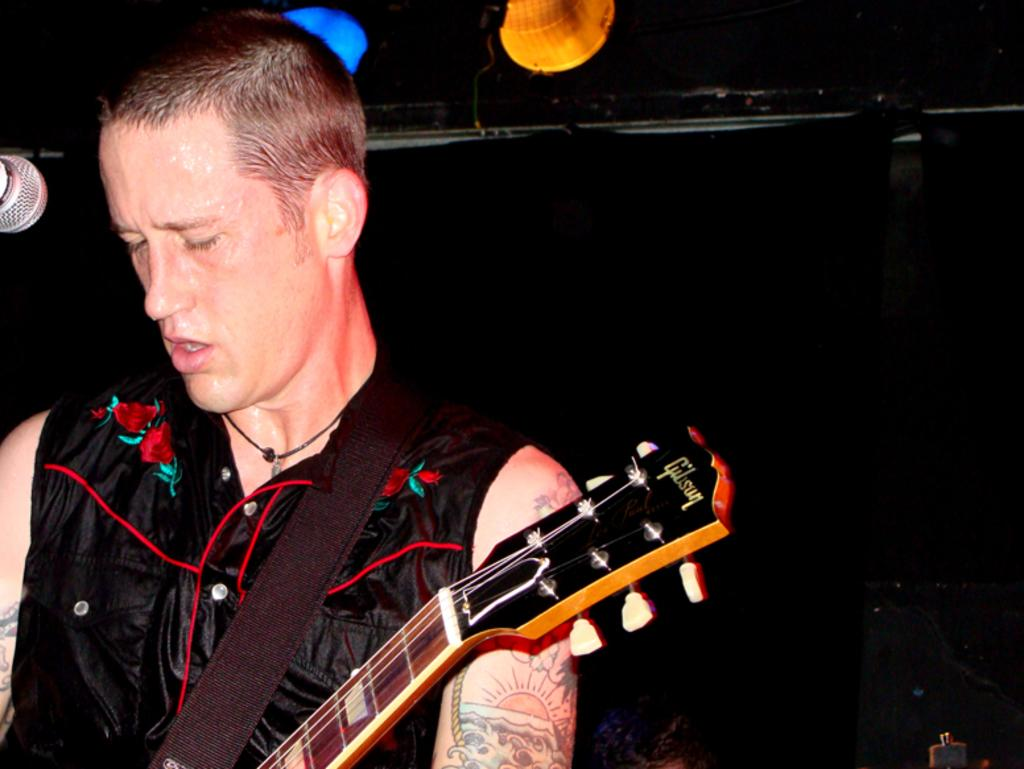What is the person in the image holding? The person is holding a musical instrument in the image. What device is present for amplifying sound? There is a microphone in the image. What can be seen in the image that provides illumination? There are lights in the image. How would you describe the overall lighting in the image? The background of the image is dark. Where is the secretary sitting in the image? There is no secretary present in the image. What type of book can be seen on the person's lap in the image? There is no book visible in the image. 